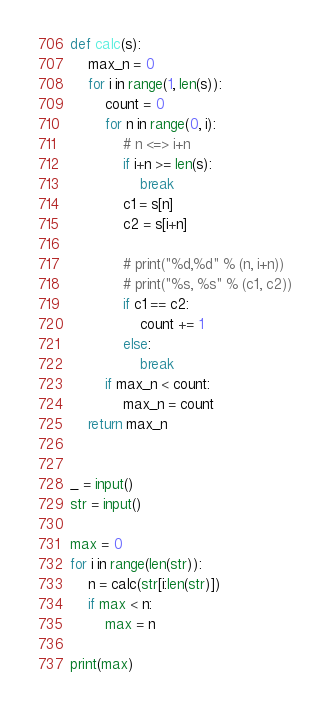Convert code to text. <code><loc_0><loc_0><loc_500><loc_500><_Python_>

def calc(s):
    max_n = 0
    for i in range(1, len(s)):
        count = 0
        for n in range(0, i):
            # n <=> i+n
            if i+n >= len(s):
                break
            c1 = s[n]
            c2 = s[i+n]

            # print("%d,%d" % (n, i+n))
            # print("%s, %s" % (c1, c2))
            if c1 == c2:
                count += 1
            else:
                break
        if max_n < count:
            max_n = count
    return max_n


_ = input()
str = input()

max = 0
for i in range(len(str)):
    n = calc(str[i:len(str)])
    if max < n:
        max = n

print(max)
</code> 